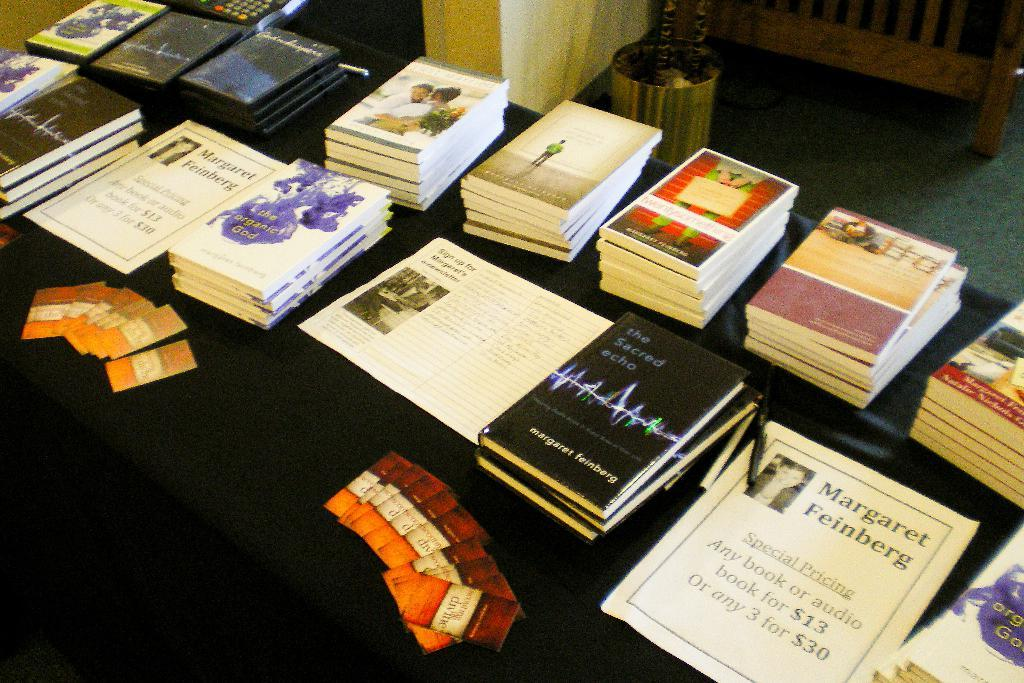<image>
Create a compact narrative representing the image presented. A table with many books sitting on it along with a Margaret Feinberg poster. 